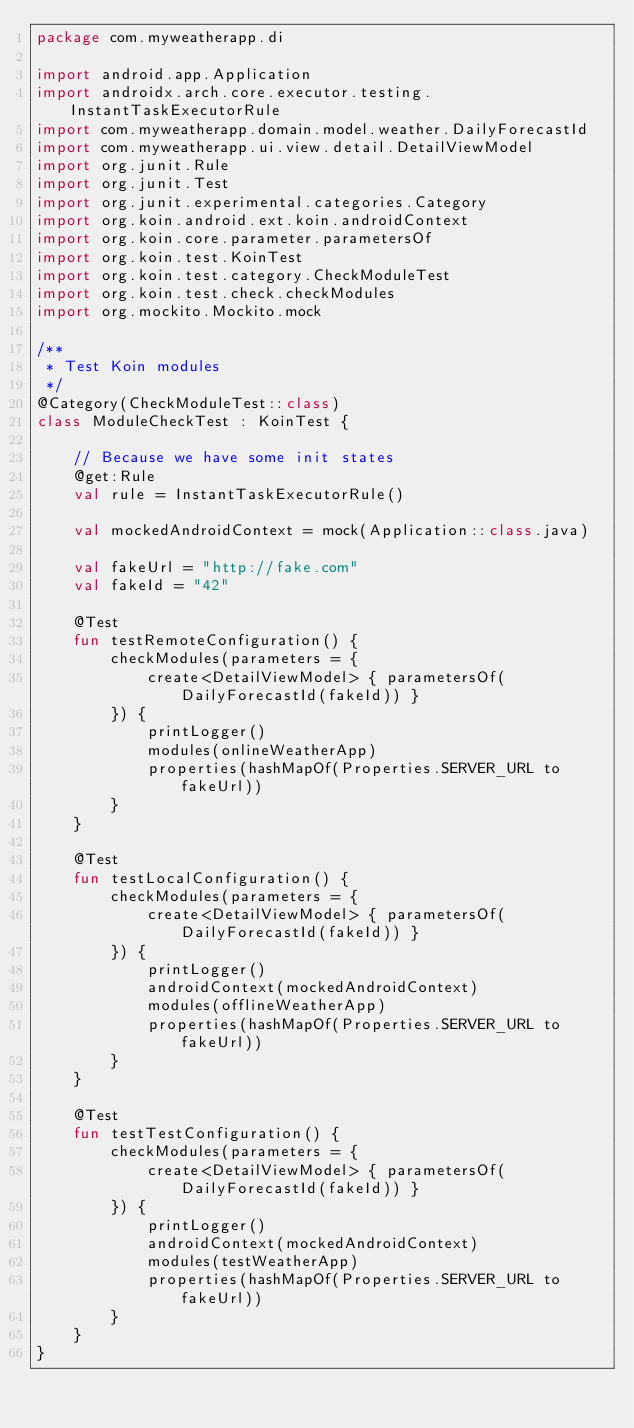Convert code to text. <code><loc_0><loc_0><loc_500><loc_500><_Kotlin_>package com.myweatherapp.di

import android.app.Application
import androidx.arch.core.executor.testing.InstantTaskExecutorRule
import com.myweatherapp.domain.model.weather.DailyForecastId
import com.myweatherapp.ui.view.detail.DetailViewModel
import org.junit.Rule
import org.junit.Test
import org.junit.experimental.categories.Category
import org.koin.android.ext.koin.androidContext
import org.koin.core.parameter.parametersOf
import org.koin.test.KoinTest
import org.koin.test.category.CheckModuleTest
import org.koin.test.check.checkModules
import org.mockito.Mockito.mock

/**
 * Test Koin modules
 */
@Category(CheckModuleTest::class)
class ModuleCheckTest : KoinTest {

    // Because we have some init states
    @get:Rule
    val rule = InstantTaskExecutorRule()

    val mockedAndroidContext = mock(Application::class.java)

    val fakeUrl = "http://fake.com"
    val fakeId = "42"

    @Test
    fun testRemoteConfiguration() {
        checkModules(parameters = {
            create<DetailViewModel> { parametersOf(DailyForecastId(fakeId)) }
        }) {
            printLogger()
            modules(onlineWeatherApp)
            properties(hashMapOf(Properties.SERVER_URL to fakeUrl))
        }
    }

    @Test
    fun testLocalConfiguration() {
        checkModules(parameters = {
            create<DetailViewModel> { parametersOf(DailyForecastId(fakeId)) }
        }) {
            printLogger()
            androidContext(mockedAndroidContext)
            modules(offlineWeatherApp)
            properties(hashMapOf(Properties.SERVER_URL to fakeUrl))
        }
    }

    @Test
    fun testTestConfiguration() {
        checkModules(parameters = {
            create<DetailViewModel> { parametersOf(DailyForecastId(fakeId)) }
        }) {
            printLogger()
            androidContext(mockedAndroidContext)
            modules(testWeatherApp)
            properties(hashMapOf(Properties.SERVER_URL to fakeUrl))
        }
    }
}</code> 